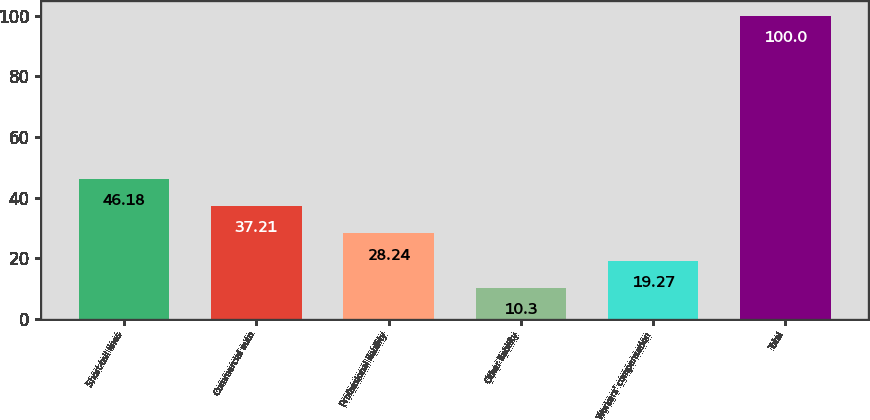<chart> <loc_0><loc_0><loc_500><loc_500><bar_chart><fcel>Short-tail lines<fcel>Commercial auto<fcel>Professional liability<fcel>Other liability<fcel>Workers' compensation<fcel>Total<nl><fcel>46.18<fcel>37.21<fcel>28.24<fcel>10.3<fcel>19.27<fcel>100<nl></chart> 